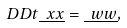Convert formula to latex. <formula><loc_0><loc_0><loc_500><loc_500>\ D D t { \underline { \ x x } } = \underline { \ w w } ,</formula> 